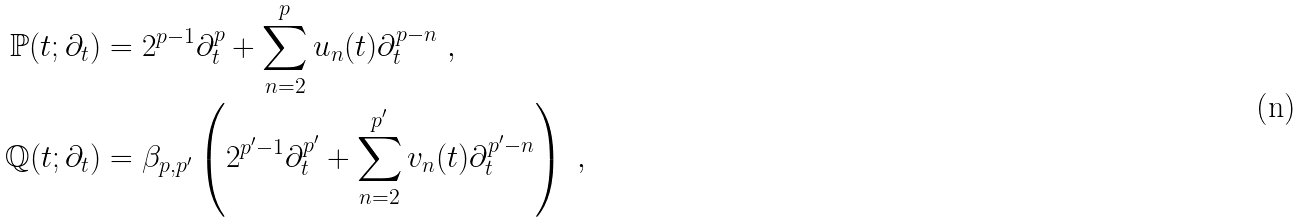<formula> <loc_0><loc_0><loc_500><loc_500>\mathbb { P } ( t ; \partial _ { t } ) & = 2 ^ { p - 1 } \partial _ { t } ^ { p } + \sum _ { n = 2 } ^ { p } u _ { n } ( t ) \partial _ { t } ^ { p - n } \ , \\ \mathbb { Q } ( t ; \partial _ { t } ) & = \beta _ { p , p ^ { \prime } } \left ( 2 ^ { p ^ { \prime } - 1 } \partial _ { t } ^ { p ^ { \prime } } + \sum _ { n = 2 } ^ { p ^ { \prime } } v _ { n } ( t ) \partial _ { t } ^ { p ^ { \prime } - n } \right ) \ ,</formula> 